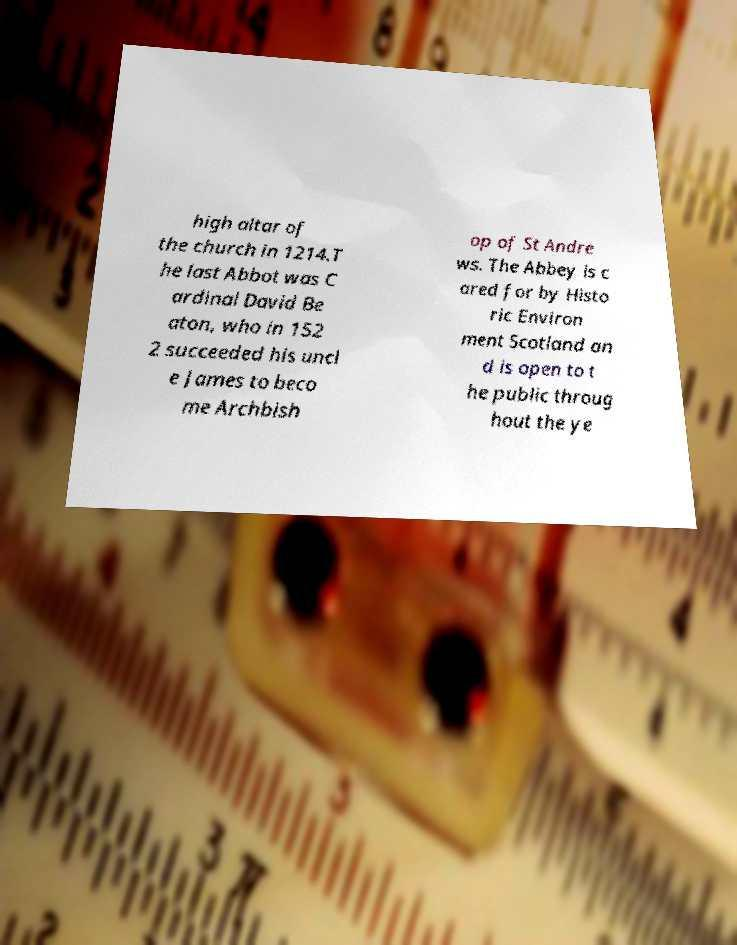Could you extract and type out the text from this image? high altar of the church in 1214.T he last Abbot was C ardinal David Be aton, who in 152 2 succeeded his uncl e James to beco me Archbish op of St Andre ws. The Abbey is c ared for by Histo ric Environ ment Scotland an d is open to t he public throug hout the ye 